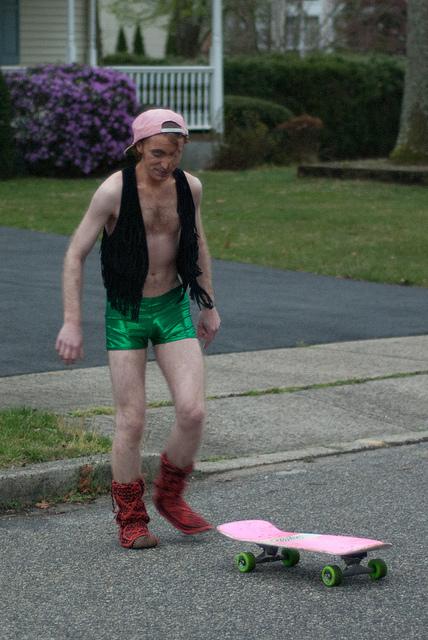What color is are the flowers?
Concise answer only. Purple. What is the man wearing on his hands?
Write a very short answer. Nothing. How sane do you think this person is?
Short answer required. Not very. What does the man have one foot on?
Give a very brief answer. Ground. Is this person safety conscious?
Concise answer only. No. What is the man attempting to mount?
Concise answer only. Skateboard. What does the man have to protect his head?
Write a very short answer. Hat. What style of homes do you see here?
Concise answer only. Ranch. Which foot does the male have on the skateboard?
Be succinct. Neither. Is there a cell phone on this picture?
Concise answer only. No. Is the man's hat on backwards or forwards?
Write a very short answer. Backwards. What type of scene is this?
Keep it brief. Street. How many men are wearing shirts?
Give a very brief answer. 0. Is the boy wearing the right shoes for skateboarding?
Short answer required. No. Where is the man?
Write a very short answer. Outside. Is this boy wearing the proper shoes to skateboard with?
Write a very short answer. No. Is the man wearing boots?
Be succinct. Yes. 